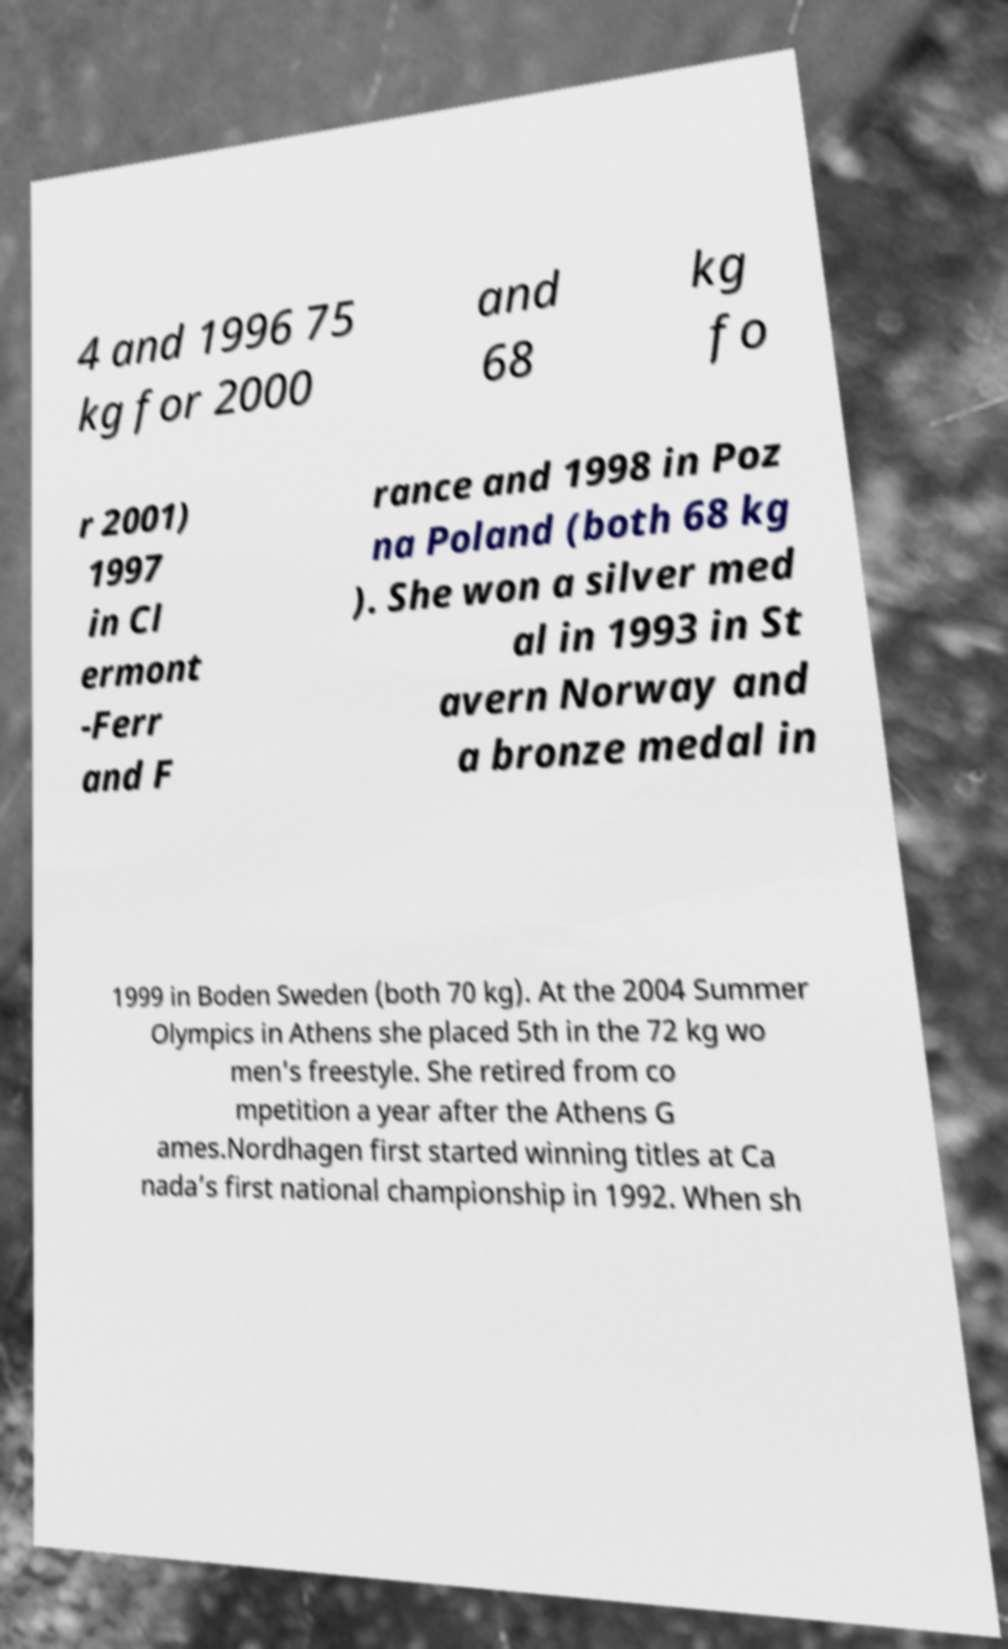There's text embedded in this image that I need extracted. Can you transcribe it verbatim? 4 and 1996 75 kg for 2000 and 68 kg fo r 2001) 1997 in Cl ermont -Ferr and F rance and 1998 in Poz na Poland (both 68 kg ). She won a silver med al in 1993 in St avern Norway and a bronze medal in 1999 in Boden Sweden (both 70 kg). At the 2004 Summer Olympics in Athens she placed 5th in the 72 kg wo men's freestyle. She retired from co mpetition a year after the Athens G ames.Nordhagen first started winning titles at Ca nada’s first national championship in 1992. When sh 